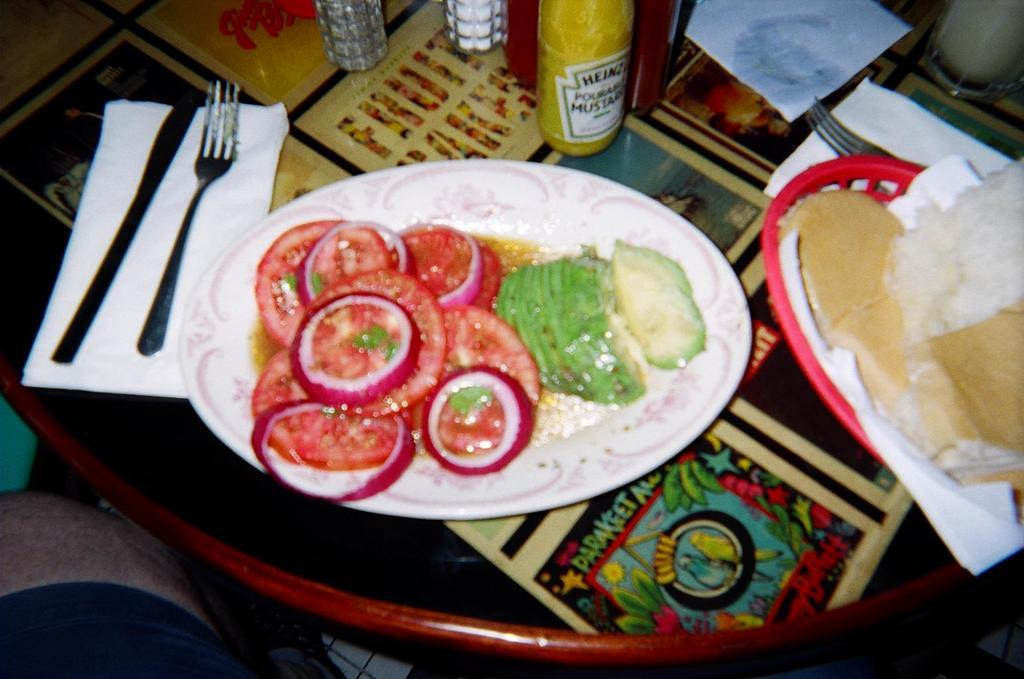What is present on the plate in the image? There is a food item on the plate in the image. What utensil is visible in the image? There is a spoon in the image. What can be used for cleaning or wiping in the image? Tissue is present in the image for cleaning or wiping. What type of containers are in the image? There are bottles in the image. Can you describe some other objects in the image? There are some other objects in the image, but their specific details are not mentioned in the provided facts. Reasoning: Let'g: Let's think step by step in order to produce the conversation. We start by identifying the main subjects and objects in the image based on the provided facts. We then formulate questions that focus on the location and characteristics of these subjects and objects, ensuring that each question can be answered definitively with the information given. We avoid yes/no questions and ensure that the language is simple and clear. Absurd Question/Answer: How do the boats affect the goose in the image? There are no boats or geese present in the image, so their interaction cannot be observed. What type of effect does the goose have on the boats in the image? There are no boats or geese present in the image, so their interaction cannot be observed. 